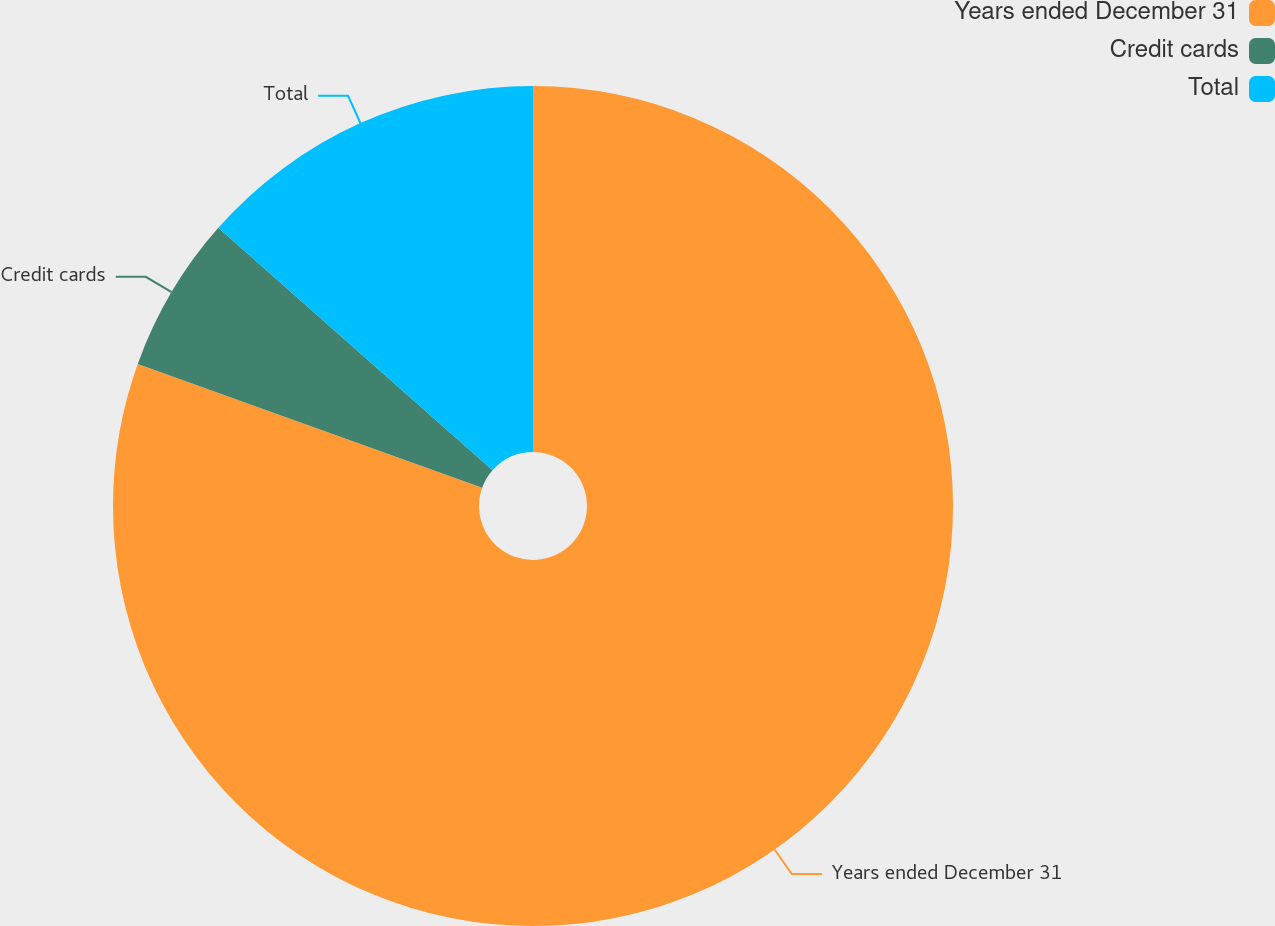Convert chart. <chart><loc_0><loc_0><loc_500><loc_500><pie_chart><fcel>Years ended December 31<fcel>Credit cards<fcel>Total<nl><fcel>80.49%<fcel>6.03%<fcel>13.48%<nl></chart> 